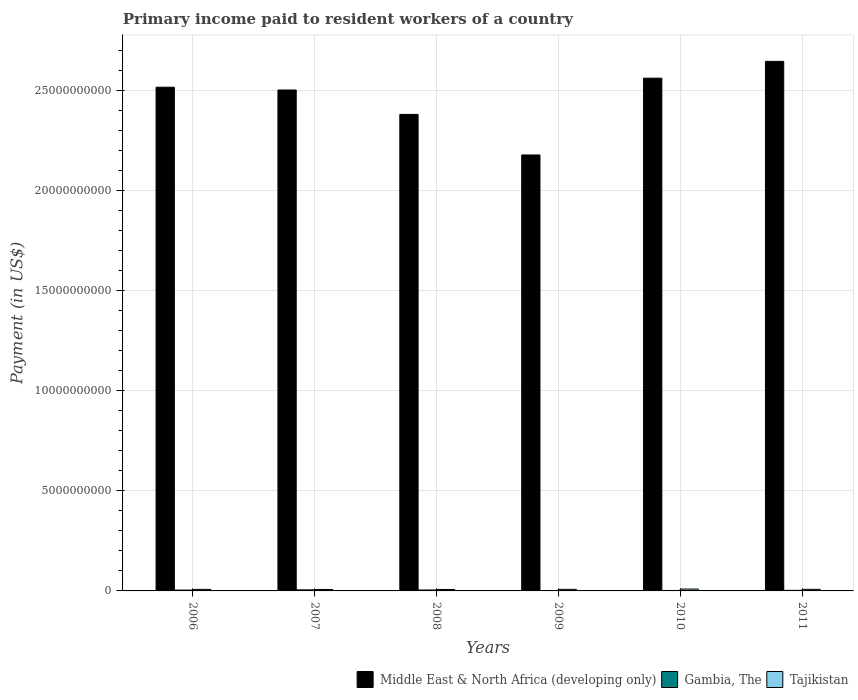Are the number of bars on each tick of the X-axis equal?
Provide a succinct answer. Yes. What is the label of the 4th group of bars from the left?
Provide a short and direct response. 2009. In how many cases, is the number of bars for a given year not equal to the number of legend labels?
Provide a succinct answer. 0. What is the amount paid to workers in Tajikistan in 2009?
Your answer should be compact. 7.85e+07. Across all years, what is the maximum amount paid to workers in Middle East & North Africa (developing only)?
Your answer should be very brief. 2.64e+1. Across all years, what is the minimum amount paid to workers in Middle East & North Africa (developing only)?
Provide a succinct answer. 2.18e+1. In which year was the amount paid to workers in Gambia, The maximum?
Provide a short and direct response. 2007. In which year was the amount paid to workers in Middle East & North Africa (developing only) minimum?
Offer a terse response. 2009. What is the total amount paid to workers in Gambia, The in the graph?
Provide a succinct answer. 2.14e+08. What is the difference between the amount paid to workers in Gambia, The in 2008 and that in 2011?
Your response must be concise. 1.84e+07. What is the difference between the amount paid to workers in Gambia, The in 2011 and the amount paid to workers in Tajikistan in 2006?
Provide a short and direct response. -4.76e+07. What is the average amount paid to workers in Middle East & North Africa (developing only) per year?
Your answer should be compact. 2.46e+1. In the year 2006, what is the difference between the amount paid to workers in Gambia, The and amount paid to workers in Middle East & North Africa (developing only)?
Provide a succinct answer. -2.51e+1. In how many years, is the amount paid to workers in Middle East & North Africa (developing only) greater than 20000000000 US$?
Provide a succinct answer. 6. What is the ratio of the amount paid to workers in Middle East & North Africa (developing only) in 2006 to that in 2011?
Your answer should be compact. 0.95. Is the amount paid to workers in Tajikistan in 2006 less than that in 2007?
Offer a very short reply. No. Is the difference between the amount paid to workers in Gambia, The in 2009 and 2011 greater than the difference between the amount paid to workers in Middle East & North Africa (developing only) in 2009 and 2011?
Offer a very short reply. Yes. What is the difference between the highest and the second highest amount paid to workers in Tajikistan?
Make the answer very short. 1.34e+07. What is the difference between the highest and the lowest amount paid to workers in Middle East & North Africa (developing only)?
Ensure brevity in your answer.  4.67e+09. Is the sum of the amount paid to workers in Gambia, The in 2009 and 2010 greater than the maximum amount paid to workers in Middle East & North Africa (developing only) across all years?
Provide a short and direct response. No. What does the 1st bar from the left in 2006 represents?
Your answer should be very brief. Middle East & North Africa (developing only). What does the 3rd bar from the right in 2009 represents?
Make the answer very short. Middle East & North Africa (developing only). How many bars are there?
Provide a succinct answer. 18. Where does the legend appear in the graph?
Offer a terse response. Bottom right. How many legend labels are there?
Offer a very short reply. 3. How are the legend labels stacked?
Provide a succinct answer. Horizontal. What is the title of the graph?
Your response must be concise. Primary income paid to resident workers of a country. What is the label or title of the Y-axis?
Offer a terse response. Payment (in US$). What is the Payment (in US$) of Middle East & North Africa (developing only) in 2006?
Provide a succinct answer. 2.52e+1. What is the Payment (in US$) of Gambia, The in 2006?
Ensure brevity in your answer.  4.24e+07. What is the Payment (in US$) in Tajikistan in 2006?
Provide a succinct answer. 7.64e+07. What is the Payment (in US$) in Middle East & North Africa (developing only) in 2007?
Ensure brevity in your answer.  2.50e+1. What is the Payment (in US$) of Gambia, The in 2007?
Your answer should be compact. 5.35e+07. What is the Payment (in US$) in Tajikistan in 2007?
Your response must be concise. 7.32e+07. What is the Payment (in US$) of Middle East & North Africa (developing only) in 2008?
Make the answer very short. 2.38e+1. What is the Payment (in US$) of Gambia, The in 2008?
Your answer should be very brief. 4.72e+07. What is the Payment (in US$) in Tajikistan in 2008?
Your response must be concise. 7.23e+07. What is the Payment (in US$) of Middle East & North Africa (developing only) in 2009?
Offer a terse response. 2.18e+1. What is the Payment (in US$) of Gambia, The in 2009?
Your response must be concise. 1.98e+07. What is the Payment (in US$) in Tajikistan in 2009?
Offer a very short reply. 7.85e+07. What is the Payment (in US$) in Middle East & North Africa (developing only) in 2010?
Give a very brief answer. 2.56e+1. What is the Payment (in US$) in Gambia, The in 2010?
Give a very brief answer. 2.24e+07. What is the Payment (in US$) of Tajikistan in 2010?
Your answer should be compact. 9.31e+07. What is the Payment (in US$) of Middle East & North Africa (developing only) in 2011?
Offer a very short reply. 2.64e+1. What is the Payment (in US$) in Gambia, The in 2011?
Offer a very short reply. 2.88e+07. What is the Payment (in US$) in Tajikistan in 2011?
Ensure brevity in your answer.  7.97e+07. Across all years, what is the maximum Payment (in US$) of Middle East & North Africa (developing only)?
Ensure brevity in your answer.  2.64e+1. Across all years, what is the maximum Payment (in US$) in Gambia, The?
Your answer should be very brief. 5.35e+07. Across all years, what is the maximum Payment (in US$) in Tajikistan?
Offer a very short reply. 9.31e+07. Across all years, what is the minimum Payment (in US$) in Middle East & North Africa (developing only)?
Your response must be concise. 2.18e+1. Across all years, what is the minimum Payment (in US$) in Gambia, The?
Offer a terse response. 1.98e+07. Across all years, what is the minimum Payment (in US$) in Tajikistan?
Provide a succinct answer. 7.23e+07. What is the total Payment (in US$) of Middle East & North Africa (developing only) in the graph?
Make the answer very short. 1.48e+11. What is the total Payment (in US$) of Gambia, The in the graph?
Ensure brevity in your answer.  2.14e+08. What is the total Payment (in US$) in Tajikistan in the graph?
Provide a succinct answer. 4.73e+08. What is the difference between the Payment (in US$) in Middle East & North Africa (developing only) in 2006 and that in 2007?
Give a very brief answer. 1.40e+08. What is the difference between the Payment (in US$) of Gambia, The in 2006 and that in 2007?
Offer a very short reply. -1.11e+07. What is the difference between the Payment (in US$) in Tajikistan in 2006 and that in 2007?
Your response must be concise. 3.18e+06. What is the difference between the Payment (in US$) in Middle East & North Africa (developing only) in 2006 and that in 2008?
Provide a succinct answer. 1.36e+09. What is the difference between the Payment (in US$) in Gambia, The in 2006 and that in 2008?
Your answer should be very brief. -4.76e+06. What is the difference between the Payment (in US$) of Tajikistan in 2006 and that in 2008?
Provide a succinct answer. 4.02e+06. What is the difference between the Payment (in US$) in Middle East & North Africa (developing only) in 2006 and that in 2009?
Make the answer very short. 3.38e+09. What is the difference between the Payment (in US$) in Gambia, The in 2006 and that in 2009?
Ensure brevity in your answer.  2.26e+07. What is the difference between the Payment (in US$) in Tajikistan in 2006 and that in 2009?
Offer a very short reply. -2.11e+06. What is the difference between the Payment (in US$) of Middle East & North Africa (developing only) in 2006 and that in 2010?
Your response must be concise. -4.51e+08. What is the difference between the Payment (in US$) of Gambia, The in 2006 and that in 2010?
Give a very brief answer. 2.00e+07. What is the difference between the Payment (in US$) in Tajikistan in 2006 and that in 2010?
Offer a very short reply. -1.68e+07. What is the difference between the Payment (in US$) of Middle East & North Africa (developing only) in 2006 and that in 2011?
Make the answer very short. -1.29e+09. What is the difference between the Payment (in US$) in Gambia, The in 2006 and that in 2011?
Offer a very short reply. 1.36e+07. What is the difference between the Payment (in US$) in Tajikistan in 2006 and that in 2011?
Offer a very short reply. -3.37e+06. What is the difference between the Payment (in US$) in Middle East & North Africa (developing only) in 2007 and that in 2008?
Provide a short and direct response. 1.22e+09. What is the difference between the Payment (in US$) in Gambia, The in 2007 and that in 2008?
Your answer should be compact. 6.37e+06. What is the difference between the Payment (in US$) of Tajikistan in 2007 and that in 2008?
Your response must be concise. 8.41e+05. What is the difference between the Payment (in US$) in Middle East & North Africa (developing only) in 2007 and that in 2009?
Make the answer very short. 3.24e+09. What is the difference between the Payment (in US$) in Gambia, The in 2007 and that in 2009?
Your response must be concise. 3.37e+07. What is the difference between the Payment (in US$) of Tajikistan in 2007 and that in 2009?
Your response must be concise. -5.30e+06. What is the difference between the Payment (in US$) in Middle East & North Africa (developing only) in 2007 and that in 2010?
Your answer should be very brief. -5.91e+08. What is the difference between the Payment (in US$) of Gambia, The in 2007 and that in 2010?
Keep it short and to the point. 3.11e+07. What is the difference between the Payment (in US$) in Tajikistan in 2007 and that in 2010?
Your response must be concise. -2.00e+07. What is the difference between the Payment (in US$) in Middle East & North Africa (developing only) in 2007 and that in 2011?
Make the answer very short. -1.43e+09. What is the difference between the Payment (in US$) of Gambia, The in 2007 and that in 2011?
Make the answer very short. 2.47e+07. What is the difference between the Payment (in US$) in Tajikistan in 2007 and that in 2011?
Make the answer very short. -6.55e+06. What is the difference between the Payment (in US$) of Middle East & North Africa (developing only) in 2008 and that in 2009?
Make the answer very short. 2.03e+09. What is the difference between the Payment (in US$) of Gambia, The in 2008 and that in 2009?
Your answer should be very brief. 2.74e+07. What is the difference between the Payment (in US$) in Tajikistan in 2008 and that in 2009?
Your answer should be very brief. -6.14e+06. What is the difference between the Payment (in US$) in Middle East & North Africa (developing only) in 2008 and that in 2010?
Your response must be concise. -1.81e+09. What is the difference between the Payment (in US$) in Gambia, The in 2008 and that in 2010?
Offer a very short reply. 2.48e+07. What is the difference between the Payment (in US$) in Tajikistan in 2008 and that in 2010?
Your answer should be very brief. -2.08e+07. What is the difference between the Payment (in US$) in Middle East & North Africa (developing only) in 2008 and that in 2011?
Offer a terse response. -2.65e+09. What is the difference between the Payment (in US$) in Gambia, The in 2008 and that in 2011?
Offer a very short reply. 1.84e+07. What is the difference between the Payment (in US$) in Tajikistan in 2008 and that in 2011?
Your answer should be very brief. -7.39e+06. What is the difference between the Payment (in US$) of Middle East & North Africa (developing only) in 2009 and that in 2010?
Offer a terse response. -3.83e+09. What is the difference between the Payment (in US$) in Gambia, The in 2009 and that in 2010?
Your answer should be very brief. -2.62e+06. What is the difference between the Payment (in US$) in Tajikistan in 2009 and that in 2010?
Give a very brief answer. -1.47e+07. What is the difference between the Payment (in US$) of Middle East & North Africa (developing only) in 2009 and that in 2011?
Your answer should be compact. -4.67e+09. What is the difference between the Payment (in US$) of Gambia, The in 2009 and that in 2011?
Give a very brief answer. -9.02e+06. What is the difference between the Payment (in US$) of Tajikistan in 2009 and that in 2011?
Give a very brief answer. -1.25e+06. What is the difference between the Payment (in US$) of Middle East & North Africa (developing only) in 2010 and that in 2011?
Provide a short and direct response. -8.40e+08. What is the difference between the Payment (in US$) in Gambia, The in 2010 and that in 2011?
Give a very brief answer. -6.40e+06. What is the difference between the Payment (in US$) of Tajikistan in 2010 and that in 2011?
Your answer should be compact. 1.34e+07. What is the difference between the Payment (in US$) of Middle East & North Africa (developing only) in 2006 and the Payment (in US$) of Gambia, The in 2007?
Keep it short and to the point. 2.51e+1. What is the difference between the Payment (in US$) in Middle East & North Africa (developing only) in 2006 and the Payment (in US$) in Tajikistan in 2007?
Keep it short and to the point. 2.51e+1. What is the difference between the Payment (in US$) of Gambia, The in 2006 and the Payment (in US$) of Tajikistan in 2007?
Offer a very short reply. -3.08e+07. What is the difference between the Payment (in US$) in Middle East & North Africa (developing only) in 2006 and the Payment (in US$) in Gambia, The in 2008?
Your answer should be very brief. 2.51e+1. What is the difference between the Payment (in US$) of Middle East & North Africa (developing only) in 2006 and the Payment (in US$) of Tajikistan in 2008?
Give a very brief answer. 2.51e+1. What is the difference between the Payment (in US$) of Gambia, The in 2006 and the Payment (in US$) of Tajikistan in 2008?
Make the answer very short. -2.99e+07. What is the difference between the Payment (in US$) in Middle East & North Africa (developing only) in 2006 and the Payment (in US$) in Gambia, The in 2009?
Give a very brief answer. 2.51e+1. What is the difference between the Payment (in US$) in Middle East & North Africa (developing only) in 2006 and the Payment (in US$) in Tajikistan in 2009?
Offer a terse response. 2.51e+1. What is the difference between the Payment (in US$) of Gambia, The in 2006 and the Payment (in US$) of Tajikistan in 2009?
Offer a very short reply. -3.61e+07. What is the difference between the Payment (in US$) of Middle East & North Africa (developing only) in 2006 and the Payment (in US$) of Gambia, The in 2010?
Ensure brevity in your answer.  2.51e+1. What is the difference between the Payment (in US$) of Middle East & North Africa (developing only) in 2006 and the Payment (in US$) of Tajikistan in 2010?
Give a very brief answer. 2.51e+1. What is the difference between the Payment (in US$) in Gambia, The in 2006 and the Payment (in US$) in Tajikistan in 2010?
Your response must be concise. -5.07e+07. What is the difference between the Payment (in US$) of Middle East & North Africa (developing only) in 2006 and the Payment (in US$) of Gambia, The in 2011?
Give a very brief answer. 2.51e+1. What is the difference between the Payment (in US$) in Middle East & North Africa (developing only) in 2006 and the Payment (in US$) in Tajikistan in 2011?
Provide a short and direct response. 2.51e+1. What is the difference between the Payment (in US$) of Gambia, The in 2006 and the Payment (in US$) of Tajikistan in 2011?
Your answer should be compact. -3.73e+07. What is the difference between the Payment (in US$) in Middle East & North Africa (developing only) in 2007 and the Payment (in US$) in Gambia, The in 2008?
Ensure brevity in your answer.  2.50e+1. What is the difference between the Payment (in US$) of Middle East & North Africa (developing only) in 2007 and the Payment (in US$) of Tajikistan in 2008?
Your response must be concise. 2.49e+1. What is the difference between the Payment (in US$) in Gambia, The in 2007 and the Payment (in US$) in Tajikistan in 2008?
Give a very brief answer. -1.88e+07. What is the difference between the Payment (in US$) in Middle East & North Africa (developing only) in 2007 and the Payment (in US$) in Gambia, The in 2009?
Make the answer very short. 2.50e+1. What is the difference between the Payment (in US$) of Middle East & North Africa (developing only) in 2007 and the Payment (in US$) of Tajikistan in 2009?
Offer a very short reply. 2.49e+1. What is the difference between the Payment (in US$) in Gambia, The in 2007 and the Payment (in US$) in Tajikistan in 2009?
Give a very brief answer. -2.49e+07. What is the difference between the Payment (in US$) in Middle East & North Africa (developing only) in 2007 and the Payment (in US$) in Gambia, The in 2010?
Offer a very short reply. 2.50e+1. What is the difference between the Payment (in US$) of Middle East & North Africa (developing only) in 2007 and the Payment (in US$) of Tajikistan in 2010?
Your answer should be compact. 2.49e+1. What is the difference between the Payment (in US$) in Gambia, The in 2007 and the Payment (in US$) in Tajikistan in 2010?
Provide a succinct answer. -3.96e+07. What is the difference between the Payment (in US$) in Middle East & North Africa (developing only) in 2007 and the Payment (in US$) in Gambia, The in 2011?
Your response must be concise. 2.50e+1. What is the difference between the Payment (in US$) in Middle East & North Africa (developing only) in 2007 and the Payment (in US$) in Tajikistan in 2011?
Ensure brevity in your answer.  2.49e+1. What is the difference between the Payment (in US$) in Gambia, The in 2007 and the Payment (in US$) in Tajikistan in 2011?
Make the answer very short. -2.62e+07. What is the difference between the Payment (in US$) of Middle East & North Africa (developing only) in 2008 and the Payment (in US$) of Gambia, The in 2009?
Provide a short and direct response. 2.38e+1. What is the difference between the Payment (in US$) of Middle East & North Africa (developing only) in 2008 and the Payment (in US$) of Tajikistan in 2009?
Your answer should be very brief. 2.37e+1. What is the difference between the Payment (in US$) in Gambia, The in 2008 and the Payment (in US$) in Tajikistan in 2009?
Your answer should be very brief. -3.13e+07. What is the difference between the Payment (in US$) in Middle East & North Africa (developing only) in 2008 and the Payment (in US$) in Gambia, The in 2010?
Make the answer very short. 2.38e+1. What is the difference between the Payment (in US$) of Middle East & North Africa (developing only) in 2008 and the Payment (in US$) of Tajikistan in 2010?
Make the answer very short. 2.37e+1. What is the difference between the Payment (in US$) of Gambia, The in 2008 and the Payment (in US$) of Tajikistan in 2010?
Provide a succinct answer. -4.60e+07. What is the difference between the Payment (in US$) of Middle East & North Africa (developing only) in 2008 and the Payment (in US$) of Gambia, The in 2011?
Your response must be concise. 2.38e+1. What is the difference between the Payment (in US$) of Middle East & North Africa (developing only) in 2008 and the Payment (in US$) of Tajikistan in 2011?
Ensure brevity in your answer.  2.37e+1. What is the difference between the Payment (in US$) of Gambia, The in 2008 and the Payment (in US$) of Tajikistan in 2011?
Your response must be concise. -3.26e+07. What is the difference between the Payment (in US$) in Middle East & North Africa (developing only) in 2009 and the Payment (in US$) in Gambia, The in 2010?
Give a very brief answer. 2.17e+1. What is the difference between the Payment (in US$) in Middle East & North Africa (developing only) in 2009 and the Payment (in US$) in Tajikistan in 2010?
Your response must be concise. 2.17e+1. What is the difference between the Payment (in US$) of Gambia, The in 2009 and the Payment (in US$) of Tajikistan in 2010?
Give a very brief answer. -7.34e+07. What is the difference between the Payment (in US$) in Middle East & North Africa (developing only) in 2009 and the Payment (in US$) in Gambia, The in 2011?
Provide a succinct answer. 2.17e+1. What is the difference between the Payment (in US$) of Middle East & North Africa (developing only) in 2009 and the Payment (in US$) of Tajikistan in 2011?
Your response must be concise. 2.17e+1. What is the difference between the Payment (in US$) in Gambia, The in 2009 and the Payment (in US$) in Tajikistan in 2011?
Give a very brief answer. -5.99e+07. What is the difference between the Payment (in US$) of Middle East & North Africa (developing only) in 2010 and the Payment (in US$) of Gambia, The in 2011?
Keep it short and to the point. 2.56e+1. What is the difference between the Payment (in US$) in Middle East & North Africa (developing only) in 2010 and the Payment (in US$) in Tajikistan in 2011?
Give a very brief answer. 2.55e+1. What is the difference between the Payment (in US$) of Gambia, The in 2010 and the Payment (in US$) of Tajikistan in 2011?
Keep it short and to the point. -5.73e+07. What is the average Payment (in US$) of Middle East & North Africa (developing only) per year?
Give a very brief answer. 2.46e+1. What is the average Payment (in US$) of Gambia, The per year?
Keep it short and to the point. 3.57e+07. What is the average Payment (in US$) in Tajikistan per year?
Your answer should be very brief. 7.89e+07. In the year 2006, what is the difference between the Payment (in US$) of Middle East & North Africa (developing only) and Payment (in US$) of Gambia, The?
Provide a succinct answer. 2.51e+1. In the year 2006, what is the difference between the Payment (in US$) of Middle East & North Africa (developing only) and Payment (in US$) of Tajikistan?
Provide a short and direct response. 2.51e+1. In the year 2006, what is the difference between the Payment (in US$) in Gambia, The and Payment (in US$) in Tajikistan?
Provide a short and direct response. -3.40e+07. In the year 2007, what is the difference between the Payment (in US$) of Middle East & North Africa (developing only) and Payment (in US$) of Gambia, The?
Make the answer very short. 2.50e+1. In the year 2007, what is the difference between the Payment (in US$) in Middle East & North Africa (developing only) and Payment (in US$) in Tajikistan?
Keep it short and to the point. 2.49e+1. In the year 2007, what is the difference between the Payment (in US$) in Gambia, The and Payment (in US$) in Tajikistan?
Your answer should be compact. -1.96e+07. In the year 2008, what is the difference between the Payment (in US$) of Middle East & North Africa (developing only) and Payment (in US$) of Gambia, The?
Offer a terse response. 2.37e+1. In the year 2008, what is the difference between the Payment (in US$) of Middle East & North Africa (developing only) and Payment (in US$) of Tajikistan?
Ensure brevity in your answer.  2.37e+1. In the year 2008, what is the difference between the Payment (in US$) in Gambia, The and Payment (in US$) in Tajikistan?
Provide a succinct answer. -2.52e+07. In the year 2009, what is the difference between the Payment (in US$) of Middle East & North Africa (developing only) and Payment (in US$) of Gambia, The?
Keep it short and to the point. 2.17e+1. In the year 2009, what is the difference between the Payment (in US$) of Middle East & North Africa (developing only) and Payment (in US$) of Tajikistan?
Provide a succinct answer. 2.17e+1. In the year 2009, what is the difference between the Payment (in US$) of Gambia, The and Payment (in US$) of Tajikistan?
Your response must be concise. -5.87e+07. In the year 2010, what is the difference between the Payment (in US$) of Middle East & North Africa (developing only) and Payment (in US$) of Gambia, The?
Make the answer very short. 2.56e+1. In the year 2010, what is the difference between the Payment (in US$) of Middle East & North Africa (developing only) and Payment (in US$) of Tajikistan?
Provide a short and direct response. 2.55e+1. In the year 2010, what is the difference between the Payment (in US$) in Gambia, The and Payment (in US$) in Tajikistan?
Offer a very short reply. -7.07e+07. In the year 2011, what is the difference between the Payment (in US$) in Middle East & North Africa (developing only) and Payment (in US$) in Gambia, The?
Ensure brevity in your answer.  2.64e+1. In the year 2011, what is the difference between the Payment (in US$) in Middle East & North Africa (developing only) and Payment (in US$) in Tajikistan?
Offer a very short reply. 2.64e+1. In the year 2011, what is the difference between the Payment (in US$) in Gambia, The and Payment (in US$) in Tajikistan?
Provide a short and direct response. -5.09e+07. What is the ratio of the Payment (in US$) of Middle East & North Africa (developing only) in 2006 to that in 2007?
Offer a terse response. 1.01. What is the ratio of the Payment (in US$) in Gambia, The in 2006 to that in 2007?
Provide a succinct answer. 0.79. What is the ratio of the Payment (in US$) in Tajikistan in 2006 to that in 2007?
Keep it short and to the point. 1.04. What is the ratio of the Payment (in US$) of Middle East & North Africa (developing only) in 2006 to that in 2008?
Offer a terse response. 1.06. What is the ratio of the Payment (in US$) of Gambia, The in 2006 to that in 2008?
Ensure brevity in your answer.  0.9. What is the ratio of the Payment (in US$) of Tajikistan in 2006 to that in 2008?
Keep it short and to the point. 1.06. What is the ratio of the Payment (in US$) in Middle East & North Africa (developing only) in 2006 to that in 2009?
Ensure brevity in your answer.  1.16. What is the ratio of the Payment (in US$) of Gambia, The in 2006 to that in 2009?
Provide a succinct answer. 2.14. What is the ratio of the Payment (in US$) in Tajikistan in 2006 to that in 2009?
Give a very brief answer. 0.97. What is the ratio of the Payment (in US$) of Middle East & North Africa (developing only) in 2006 to that in 2010?
Your answer should be very brief. 0.98. What is the ratio of the Payment (in US$) in Gambia, The in 2006 to that in 2010?
Your answer should be compact. 1.89. What is the ratio of the Payment (in US$) of Tajikistan in 2006 to that in 2010?
Your answer should be compact. 0.82. What is the ratio of the Payment (in US$) in Middle East & North Africa (developing only) in 2006 to that in 2011?
Your answer should be very brief. 0.95. What is the ratio of the Payment (in US$) in Gambia, The in 2006 to that in 2011?
Provide a short and direct response. 1.47. What is the ratio of the Payment (in US$) of Tajikistan in 2006 to that in 2011?
Your answer should be very brief. 0.96. What is the ratio of the Payment (in US$) in Middle East & North Africa (developing only) in 2007 to that in 2008?
Give a very brief answer. 1.05. What is the ratio of the Payment (in US$) of Gambia, The in 2007 to that in 2008?
Keep it short and to the point. 1.14. What is the ratio of the Payment (in US$) of Tajikistan in 2007 to that in 2008?
Offer a very short reply. 1.01. What is the ratio of the Payment (in US$) in Middle East & North Africa (developing only) in 2007 to that in 2009?
Ensure brevity in your answer.  1.15. What is the ratio of the Payment (in US$) of Gambia, The in 2007 to that in 2009?
Provide a succinct answer. 2.71. What is the ratio of the Payment (in US$) in Tajikistan in 2007 to that in 2009?
Your answer should be compact. 0.93. What is the ratio of the Payment (in US$) of Middle East & North Africa (developing only) in 2007 to that in 2010?
Keep it short and to the point. 0.98. What is the ratio of the Payment (in US$) of Gambia, The in 2007 to that in 2010?
Your answer should be compact. 2.39. What is the ratio of the Payment (in US$) of Tajikistan in 2007 to that in 2010?
Give a very brief answer. 0.79. What is the ratio of the Payment (in US$) of Middle East & North Africa (developing only) in 2007 to that in 2011?
Provide a short and direct response. 0.95. What is the ratio of the Payment (in US$) in Gambia, The in 2007 to that in 2011?
Your answer should be compact. 1.86. What is the ratio of the Payment (in US$) of Tajikistan in 2007 to that in 2011?
Offer a very short reply. 0.92. What is the ratio of the Payment (in US$) of Middle East & North Africa (developing only) in 2008 to that in 2009?
Your answer should be very brief. 1.09. What is the ratio of the Payment (in US$) in Gambia, The in 2008 to that in 2009?
Your response must be concise. 2.38. What is the ratio of the Payment (in US$) in Tajikistan in 2008 to that in 2009?
Offer a very short reply. 0.92. What is the ratio of the Payment (in US$) in Middle East & North Africa (developing only) in 2008 to that in 2010?
Provide a succinct answer. 0.93. What is the ratio of the Payment (in US$) of Gambia, The in 2008 to that in 2010?
Offer a very short reply. 2.11. What is the ratio of the Payment (in US$) in Tajikistan in 2008 to that in 2010?
Your response must be concise. 0.78. What is the ratio of the Payment (in US$) in Middle East & North Africa (developing only) in 2008 to that in 2011?
Give a very brief answer. 0.9. What is the ratio of the Payment (in US$) of Gambia, The in 2008 to that in 2011?
Ensure brevity in your answer.  1.64. What is the ratio of the Payment (in US$) in Tajikistan in 2008 to that in 2011?
Your response must be concise. 0.91. What is the ratio of the Payment (in US$) of Middle East & North Africa (developing only) in 2009 to that in 2010?
Your answer should be compact. 0.85. What is the ratio of the Payment (in US$) in Gambia, The in 2009 to that in 2010?
Give a very brief answer. 0.88. What is the ratio of the Payment (in US$) in Tajikistan in 2009 to that in 2010?
Offer a very short reply. 0.84. What is the ratio of the Payment (in US$) of Middle East & North Africa (developing only) in 2009 to that in 2011?
Offer a very short reply. 0.82. What is the ratio of the Payment (in US$) of Gambia, The in 2009 to that in 2011?
Your response must be concise. 0.69. What is the ratio of the Payment (in US$) of Tajikistan in 2009 to that in 2011?
Your answer should be very brief. 0.98. What is the ratio of the Payment (in US$) of Middle East & North Africa (developing only) in 2010 to that in 2011?
Your answer should be very brief. 0.97. What is the ratio of the Payment (in US$) of Gambia, The in 2010 to that in 2011?
Give a very brief answer. 0.78. What is the ratio of the Payment (in US$) in Tajikistan in 2010 to that in 2011?
Make the answer very short. 1.17. What is the difference between the highest and the second highest Payment (in US$) of Middle East & North Africa (developing only)?
Your answer should be compact. 8.40e+08. What is the difference between the highest and the second highest Payment (in US$) of Gambia, The?
Give a very brief answer. 6.37e+06. What is the difference between the highest and the second highest Payment (in US$) in Tajikistan?
Make the answer very short. 1.34e+07. What is the difference between the highest and the lowest Payment (in US$) of Middle East & North Africa (developing only)?
Give a very brief answer. 4.67e+09. What is the difference between the highest and the lowest Payment (in US$) in Gambia, The?
Your answer should be very brief. 3.37e+07. What is the difference between the highest and the lowest Payment (in US$) of Tajikistan?
Give a very brief answer. 2.08e+07. 